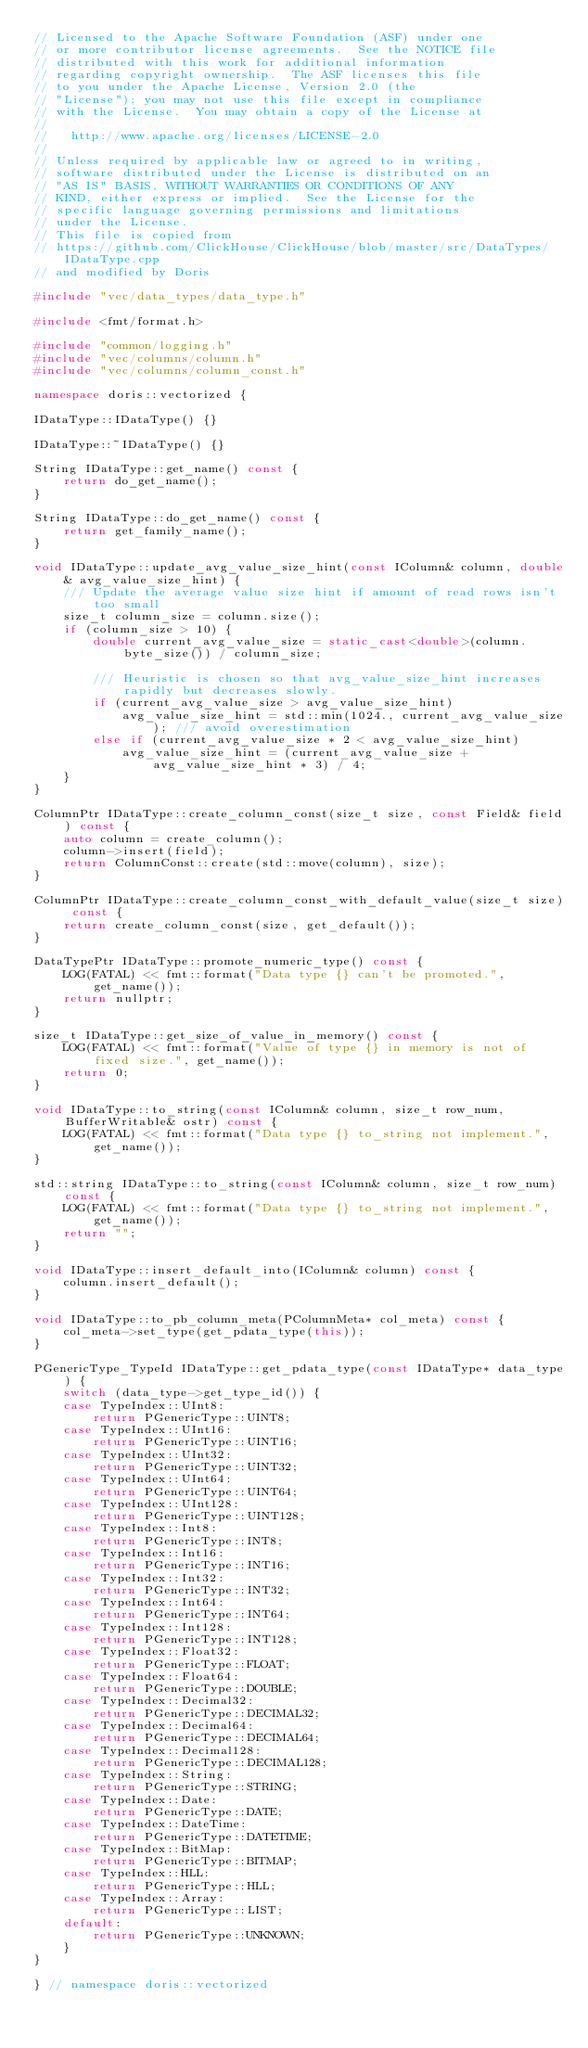<code> <loc_0><loc_0><loc_500><loc_500><_C++_>// Licensed to the Apache Software Foundation (ASF) under one
// or more contributor license agreements.  See the NOTICE file
// distributed with this work for additional information
// regarding copyright ownership.  The ASF licenses this file
// to you under the Apache License, Version 2.0 (the
// "License"); you may not use this file except in compliance
// with the License.  You may obtain a copy of the License at
//
//   http://www.apache.org/licenses/LICENSE-2.0
//
// Unless required by applicable law or agreed to in writing,
// software distributed under the License is distributed on an
// "AS IS" BASIS, WITHOUT WARRANTIES OR CONDITIONS OF ANY
// KIND, either express or implied.  See the License for the
// specific language governing permissions and limitations
// under the License.
// This file is copied from
// https://github.com/ClickHouse/ClickHouse/blob/master/src/DataTypes/IDataType.cpp
// and modified by Doris

#include "vec/data_types/data_type.h"

#include <fmt/format.h>

#include "common/logging.h"
#include "vec/columns/column.h"
#include "vec/columns/column_const.h"

namespace doris::vectorized {

IDataType::IDataType() {}

IDataType::~IDataType() {}

String IDataType::get_name() const {
    return do_get_name();
}

String IDataType::do_get_name() const {
    return get_family_name();
}

void IDataType::update_avg_value_size_hint(const IColumn& column, double& avg_value_size_hint) {
    /// Update the average value size hint if amount of read rows isn't too small
    size_t column_size = column.size();
    if (column_size > 10) {
        double current_avg_value_size = static_cast<double>(column.byte_size()) / column_size;

        /// Heuristic is chosen so that avg_value_size_hint increases rapidly but decreases slowly.
        if (current_avg_value_size > avg_value_size_hint)
            avg_value_size_hint = std::min(1024., current_avg_value_size); /// avoid overestimation
        else if (current_avg_value_size * 2 < avg_value_size_hint)
            avg_value_size_hint = (current_avg_value_size + avg_value_size_hint * 3) / 4;
    }
}

ColumnPtr IDataType::create_column_const(size_t size, const Field& field) const {
    auto column = create_column();
    column->insert(field);
    return ColumnConst::create(std::move(column), size);
}

ColumnPtr IDataType::create_column_const_with_default_value(size_t size) const {
    return create_column_const(size, get_default());
}

DataTypePtr IDataType::promote_numeric_type() const {
    LOG(FATAL) << fmt::format("Data type {} can't be promoted.", get_name());
    return nullptr;
}

size_t IDataType::get_size_of_value_in_memory() const {
    LOG(FATAL) << fmt::format("Value of type {} in memory is not of fixed size.", get_name());
    return 0;
}

void IDataType::to_string(const IColumn& column, size_t row_num, BufferWritable& ostr) const {
    LOG(FATAL) << fmt::format("Data type {} to_string not implement.", get_name());
}

std::string IDataType::to_string(const IColumn& column, size_t row_num) const {
    LOG(FATAL) << fmt::format("Data type {} to_string not implement.", get_name());
    return "";
}

void IDataType::insert_default_into(IColumn& column) const {
    column.insert_default();
}

void IDataType::to_pb_column_meta(PColumnMeta* col_meta) const {
    col_meta->set_type(get_pdata_type(this));
}

PGenericType_TypeId IDataType::get_pdata_type(const IDataType* data_type) {
    switch (data_type->get_type_id()) {
    case TypeIndex::UInt8:
        return PGenericType::UINT8;
    case TypeIndex::UInt16:
        return PGenericType::UINT16;
    case TypeIndex::UInt32:
        return PGenericType::UINT32;
    case TypeIndex::UInt64:
        return PGenericType::UINT64;
    case TypeIndex::UInt128:
        return PGenericType::UINT128;
    case TypeIndex::Int8:
        return PGenericType::INT8;
    case TypeIndex::Int16:
        return PGenericType::INT16;
    case TypeIndex::Int32:
        return PGenericType::INT32;
    case TypeIndex::Int64:
        return PGenericType::INT64;
    case TypeIndex::Int128:
        return PGenericType::INT128;
    case TypeIndex::Float32:
        return PGenericType::FLOAT;
    case TypeIndex::Float64:
        return PGenericType::DOUBLE;
    case TypeIndex::Decimal32:
        return PGenericType::DECIMAL32;
    case TypeIndex::Decimal64:
        return PGenericType::DECIMAL64;
    case TypeIndex::Decimal128:
        return PGenericType::DECIMAL128;
    case TypeIndex::String:
        return PGenericType::STRING;
    case TypeIndex::Date:
        return PGenericType::DATE;
    case TypeIndex::DateTime:
        return PGenericType::DATETIME;
    case TypeIndex::BitMap:
        return PGenericType::BITMAP;
    case TypeIndex::HLL:
        return PGenericType::HLL;
    case TypeIndex::Array:
        return PGenericType::LIST;
    default:
        return PGenericType::UNKNOWN;
    }
}

} // namespace doris::vectorized
</code> 